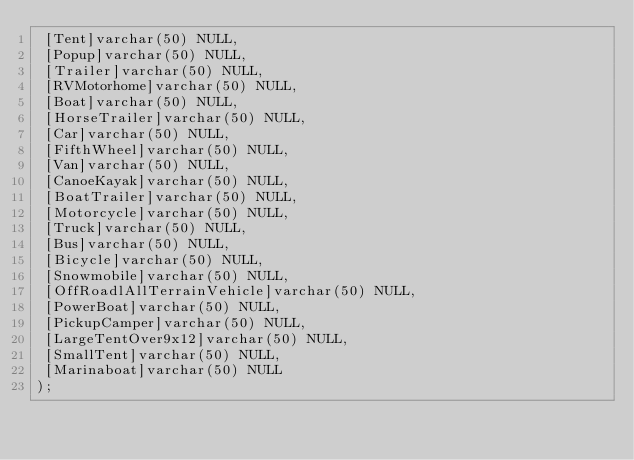<code> <loc_0><loc_0><loc_500><loc_500><_SQL_> [Tent]varchar(50) NULL,
 [Popup]varchar(50) NULL,
 [Trailer]varchar(50) NULL,
 [RVMotorhome]varchar(50) NULL,
 [Boat]varchar(50) NULL,
 [HorseTrailer]varchar(50) NULL,
 [Car]varchar(50) NULL,
 [FifthWheel]varchar(50) NULL,
 [Van]varchar(50) NULL,
 [CanoeKayak]varchar(50) NULL,
 [BoatTrailer]varchar(50) NULL,
 [Motorcycle]varchar(50) NULL,
 [Truck]varchar(50) NULL,
 [Bus]varchar(50) NULL,
 [Bicycle]varchar(50) NULL,
 [Snowmobile]varchar(50) NULL,
 [OffRoadlAllTerrainVehicle]varchar(50) NULL,
 [PowerBoat]varchar(50) NULL,
 [PickupCamper]varchar(50) NULL,
 [LargeTentOver9x12]varchar(50) NULL,
 [SmallTent]varchar(50) NULL,
 [Marinaboat]varchar(50) NULL
);</code> 